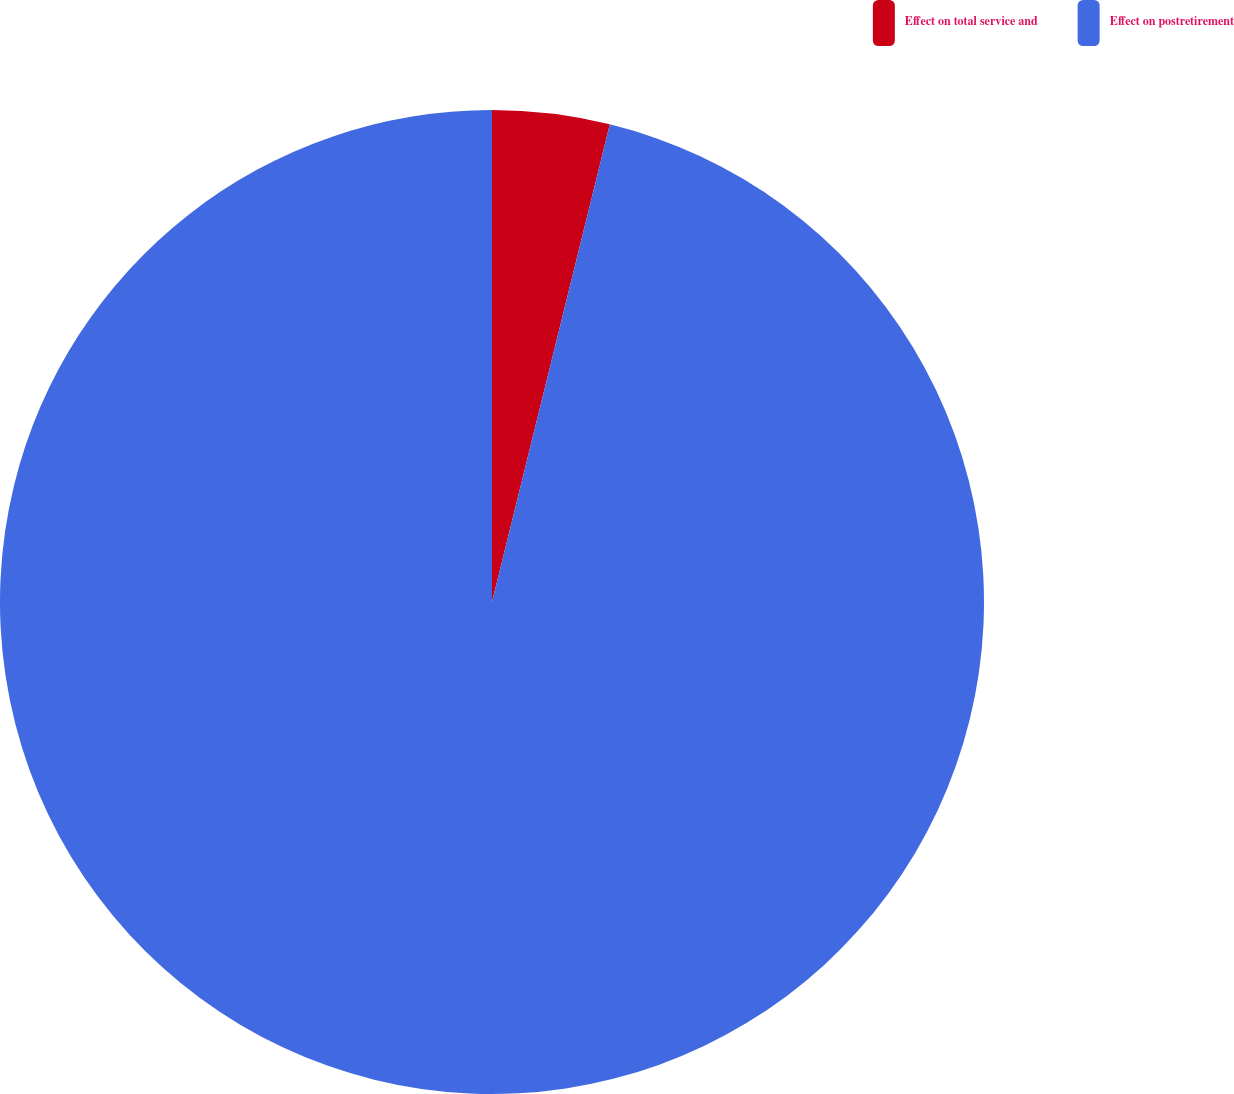Convert chart to OTSL. <chart><loc_0><loc_0><loc_500><loc_500><pie_chart><fcel>Effect on total service and<fcel>Effect on postretirement<nl><fcel>3.85%<fcel>96.15%<nl></chart> 